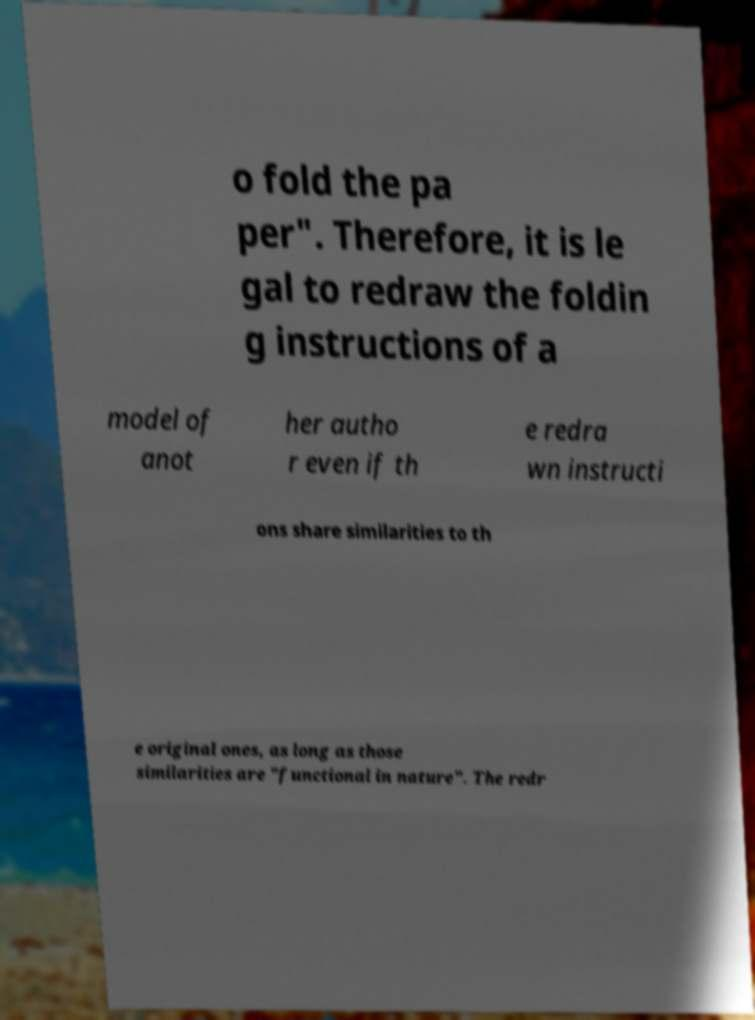Please read and relay the text visible in this image. What does it say? o fold the pa per". Therefore, it is le gal to redraw the foldin g instructions of a model of anot her autho r even if th e redra wn instructi ons share similarities to th e original ones, as long as those similarities are "functional in nature". The redr 